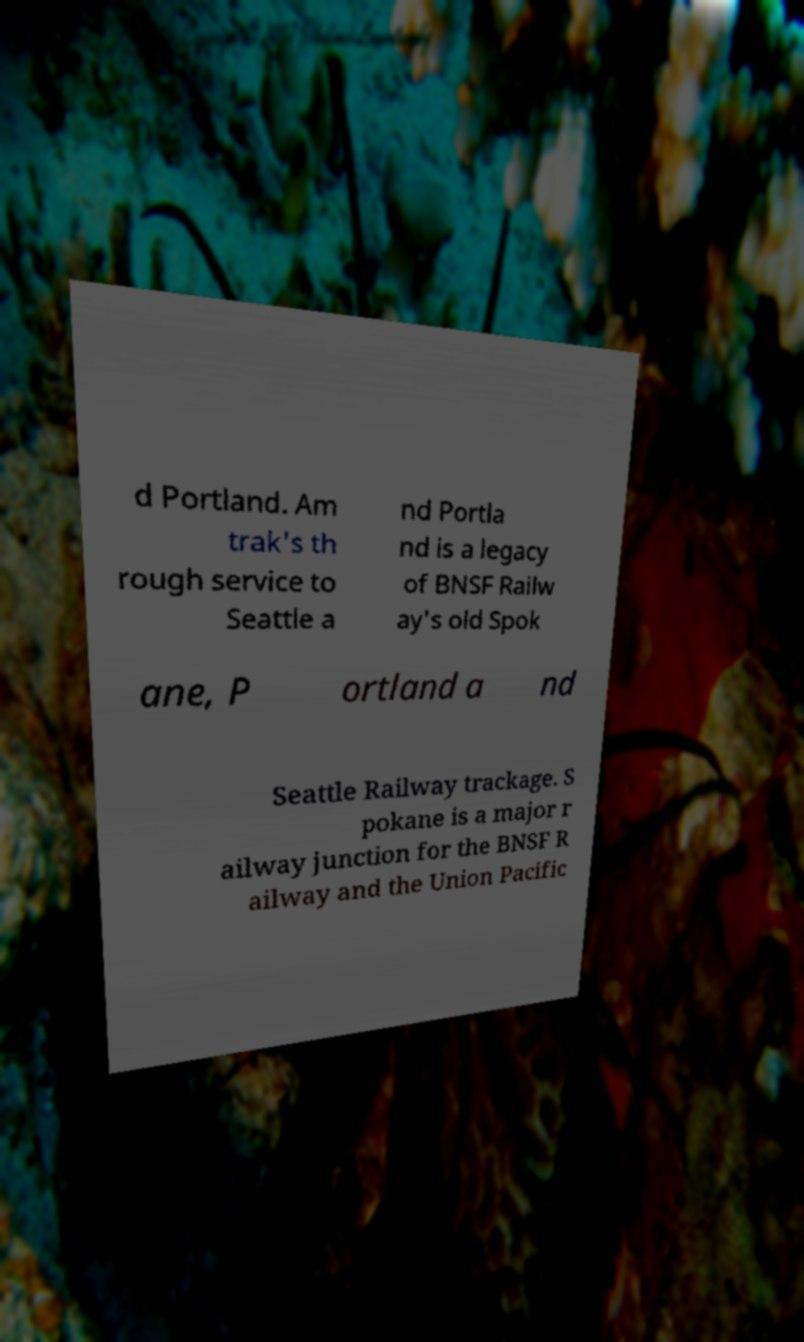For documentation purposes, I need the text within this image transcribed. Could you provide that? d Portland. Am trak's th rough service to Seattle a nd Portla nd is a legacy of BNSF Railw ay's old Spok ane, P ortland a nd Seattle Railway trackage. S pokane is a major r ailway junction for the BNSF R ailway and the Union Pacific 